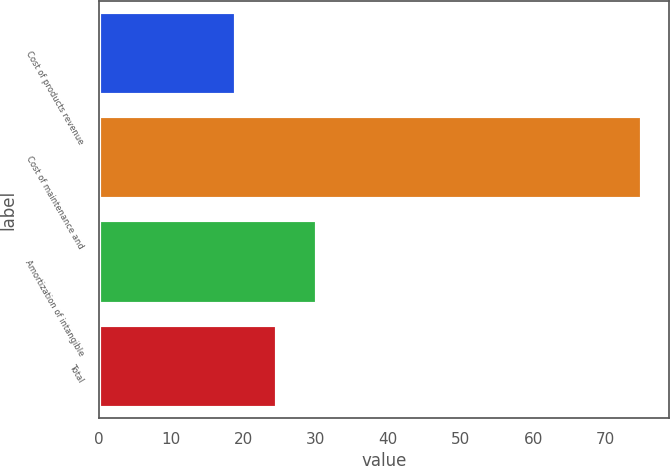Convert chart. <chart><loc_0><loc_0><loc_500><loc_500><bar_chart><fcel>Cost of products revenue<fcel>Cost of maintenance and<fcel>Amortization of intangible<fcel>Total<nl><fcel>19<fcel>75<fcel>30.2<fcel>24.6<nl></chart> 